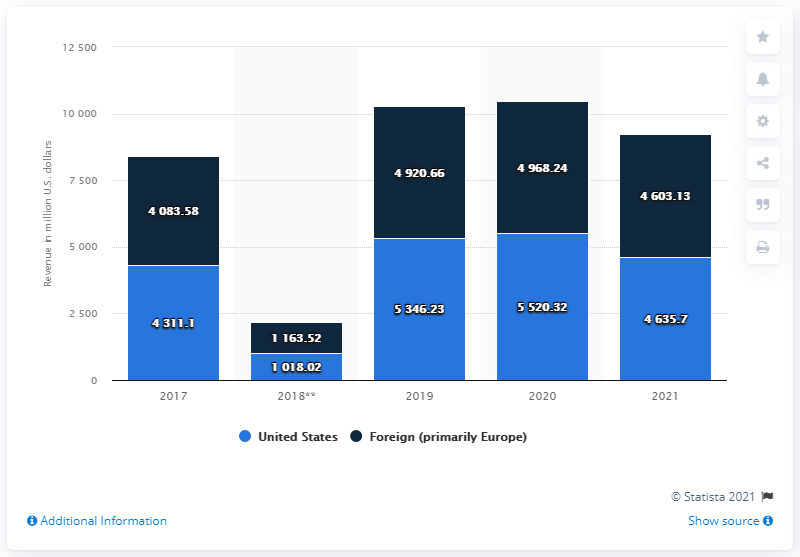Specify some key components in this picture. According to the information available, the VF Corporation generated approximately 4635.7 million dollars in the United States in 2021. 